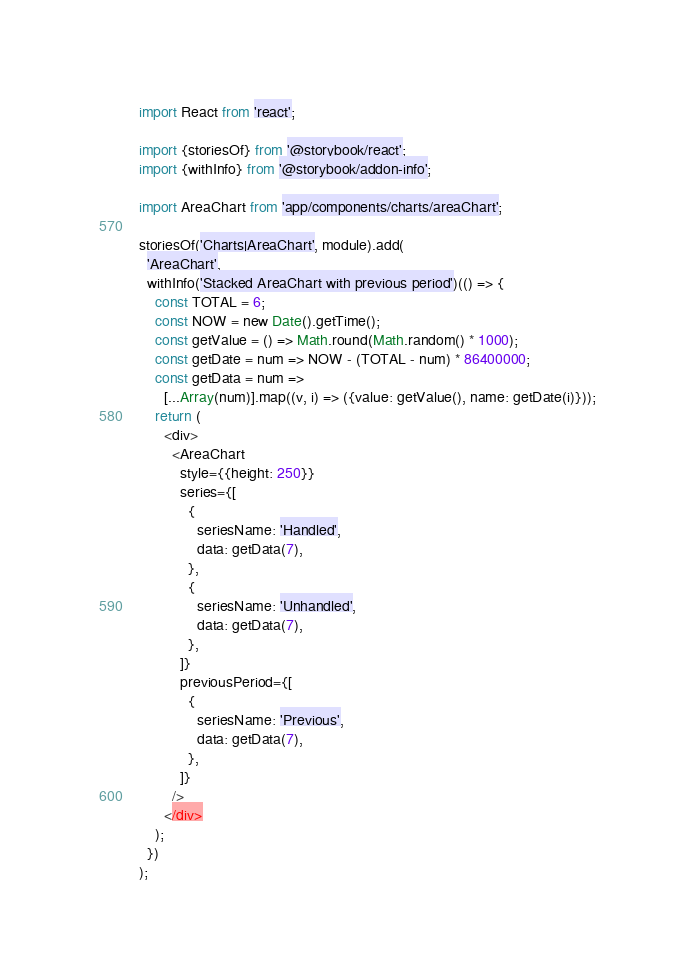<code> <loc_0><loc_0><loc_500><loc_500><_JavaScript_>import React from 'react';

import {storiesOf} from '@storybook/react';
import {withInfo} from '@storybook/addon-info';

import AreaChart from 'app/components/charts/areaChart';

storiesOf('Charts|AreaChart', module).add(
  'AreaChart',
  withInfo('Stacked AreaChart with previous period')(() => {
    const TOTAL = 6;
    const NOW = new Date().getTime();
    const getValue = () => Math.round(Math.random() * 1000);
    const getDate = num => NOW - (TOTAL - num) * 86400000;
    const getData = num =>
      [...Array(num)].map((v, i) => ({value: getValue(), name: getDate(i)}));
    return (
      <div>
        <AreaChart
          style={{height: 250}}
          series={[
            {
              seriesName: 'Handled',
              data: getData(7),
            },
            {
              seriesName: 'Unhandled',
              data: getData(7),
            },
          ]}
          previousPeriod={[
            {
              seriesName: 'Previous',
              data: getData(7),
            },
          ]}
        />
      </div>
    );
  })
);
</code> 